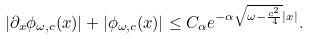<formula> <loc_0><loc_0><loc_500><loc_500>| \partial _ { x } \phi _ { \omega , c } ( x ) | + | \phi _ { \omega , c } ( x ) | \leq C _ { \alpha } e ^ { - \alpha \sqrt { \omega - \frac { c ^ { 2 } } { 4 } } | x | } .</formula> 